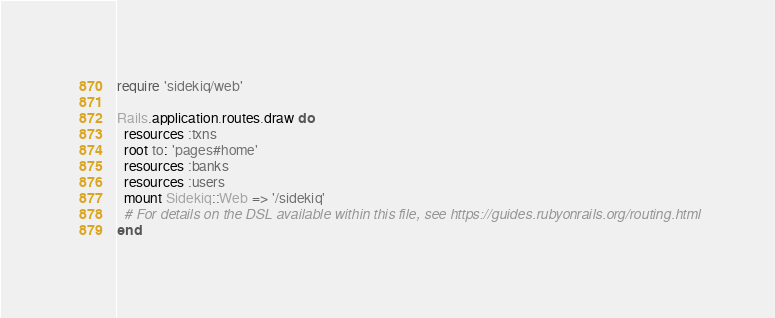<code> <loc_0><loc_0><loc_500><loc_500><_Ruby_>require 'sidekiq/web'

Rails.application.routes.draw do
  resources :txns
  root to: 'pages#home'
  resources :banks
  resources :users
  mount Sidekiq::Web => '/sidekiq'
  # For details on the DSL available within this file, see https://guides.rubyonrails.org/routing.html
end
</code> 